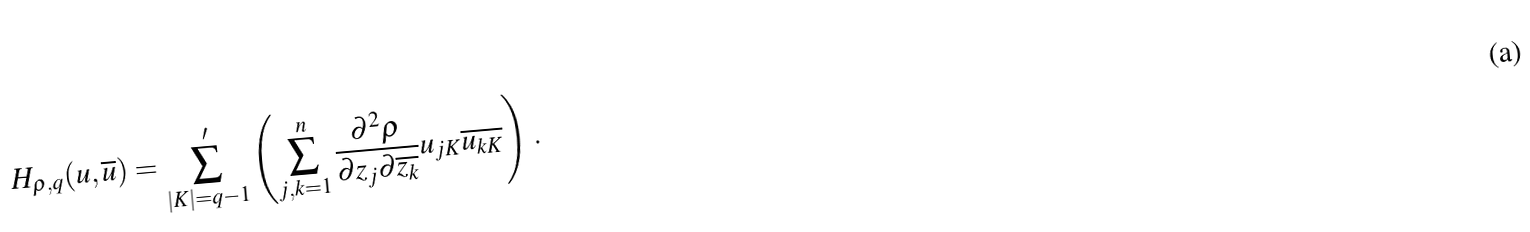<formula> <loc_0><loc_0><loc_500><loc_500>H _ { \rho , q } ( u , \overline { u } ) = \sum _ { | K | = q - 1 } ^ { \prime } \left ( \sum _ { j , k = 1 } ^ { n } \frac { \partial ^ { 2 } \rho } { \partial z _ { j } \partial \overline { z _ { k } } } u _ { j K } \overline { u _ { k K } } \right ) \, .</formula> 